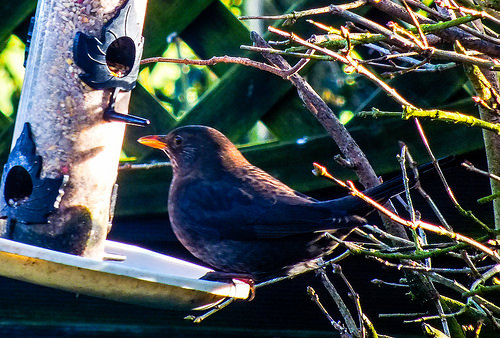<image>
Is the bird in front of the branch? Yes. The bird is positioned in front of the branch, appearing closer to the camera viewpoint. 